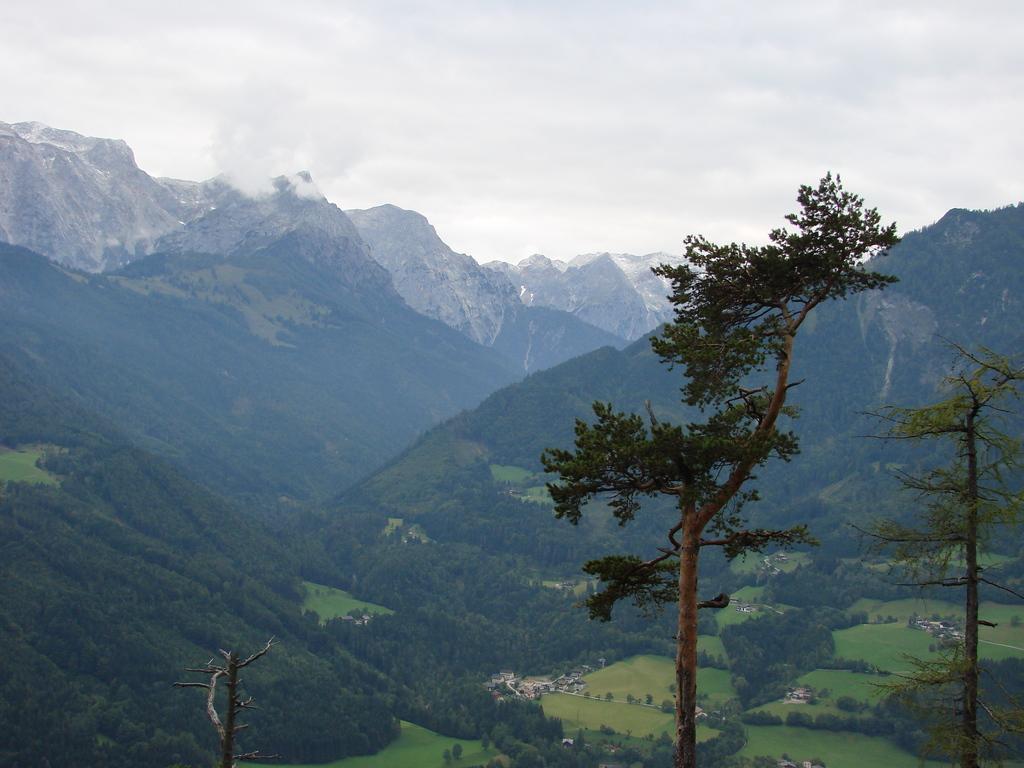Could you give a brief overview of what you see in this image? This picture is clicked outside. In the foreground we can see the trees, plants and grass and we can see some other objects. In the background we can see the sky which is full of clouds and we can see the mountains. 